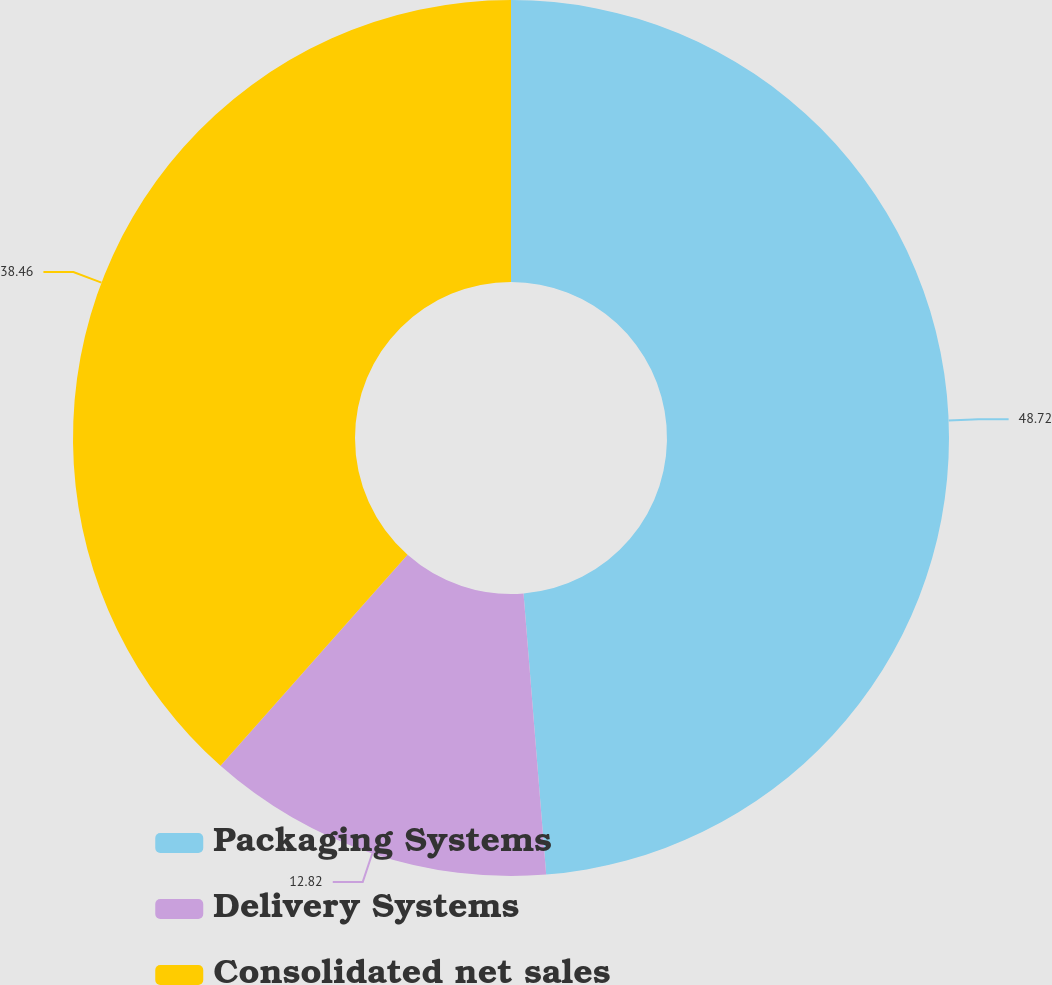Convert chart. <chart><loc_0><loc_0><loc_500><loc_500><pie_chart><fcel>Packaging Systems<fcel>Delivery Systems<fcel>Consolidated net sales<nl><fcel>48.72%<fcel>12.82%<fcel>38.46%<nl></chart> 